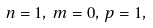<formula> <loc_0><loc_0><loc_500><loc_500>n = 1 , \, m = 0 , \, p = 1 ,</formula> 